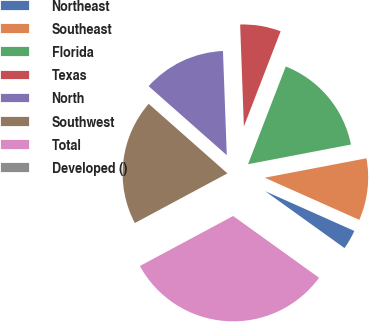Convert chart. <chart><loc_0><loc_0><loc_500><loc_500><pie_chart><fcel>Northeast<fcel>Southeast<fcel>Florida<fcel>Texas<fcel>North<fcel>Southwest<fcel>Total<fcel>Developed ()<nl><fcel>3.23%<fcel>9.68%<fcel>16.13%<fcel>6.45%<fcel>12.9%<fcel>19.35%<fcel>32.25%<fcel>0.01%<nl></chart> 